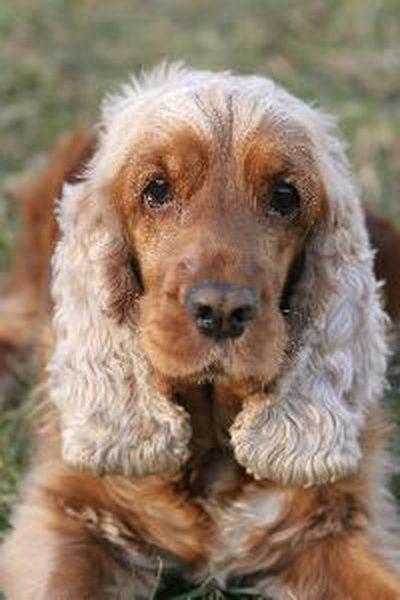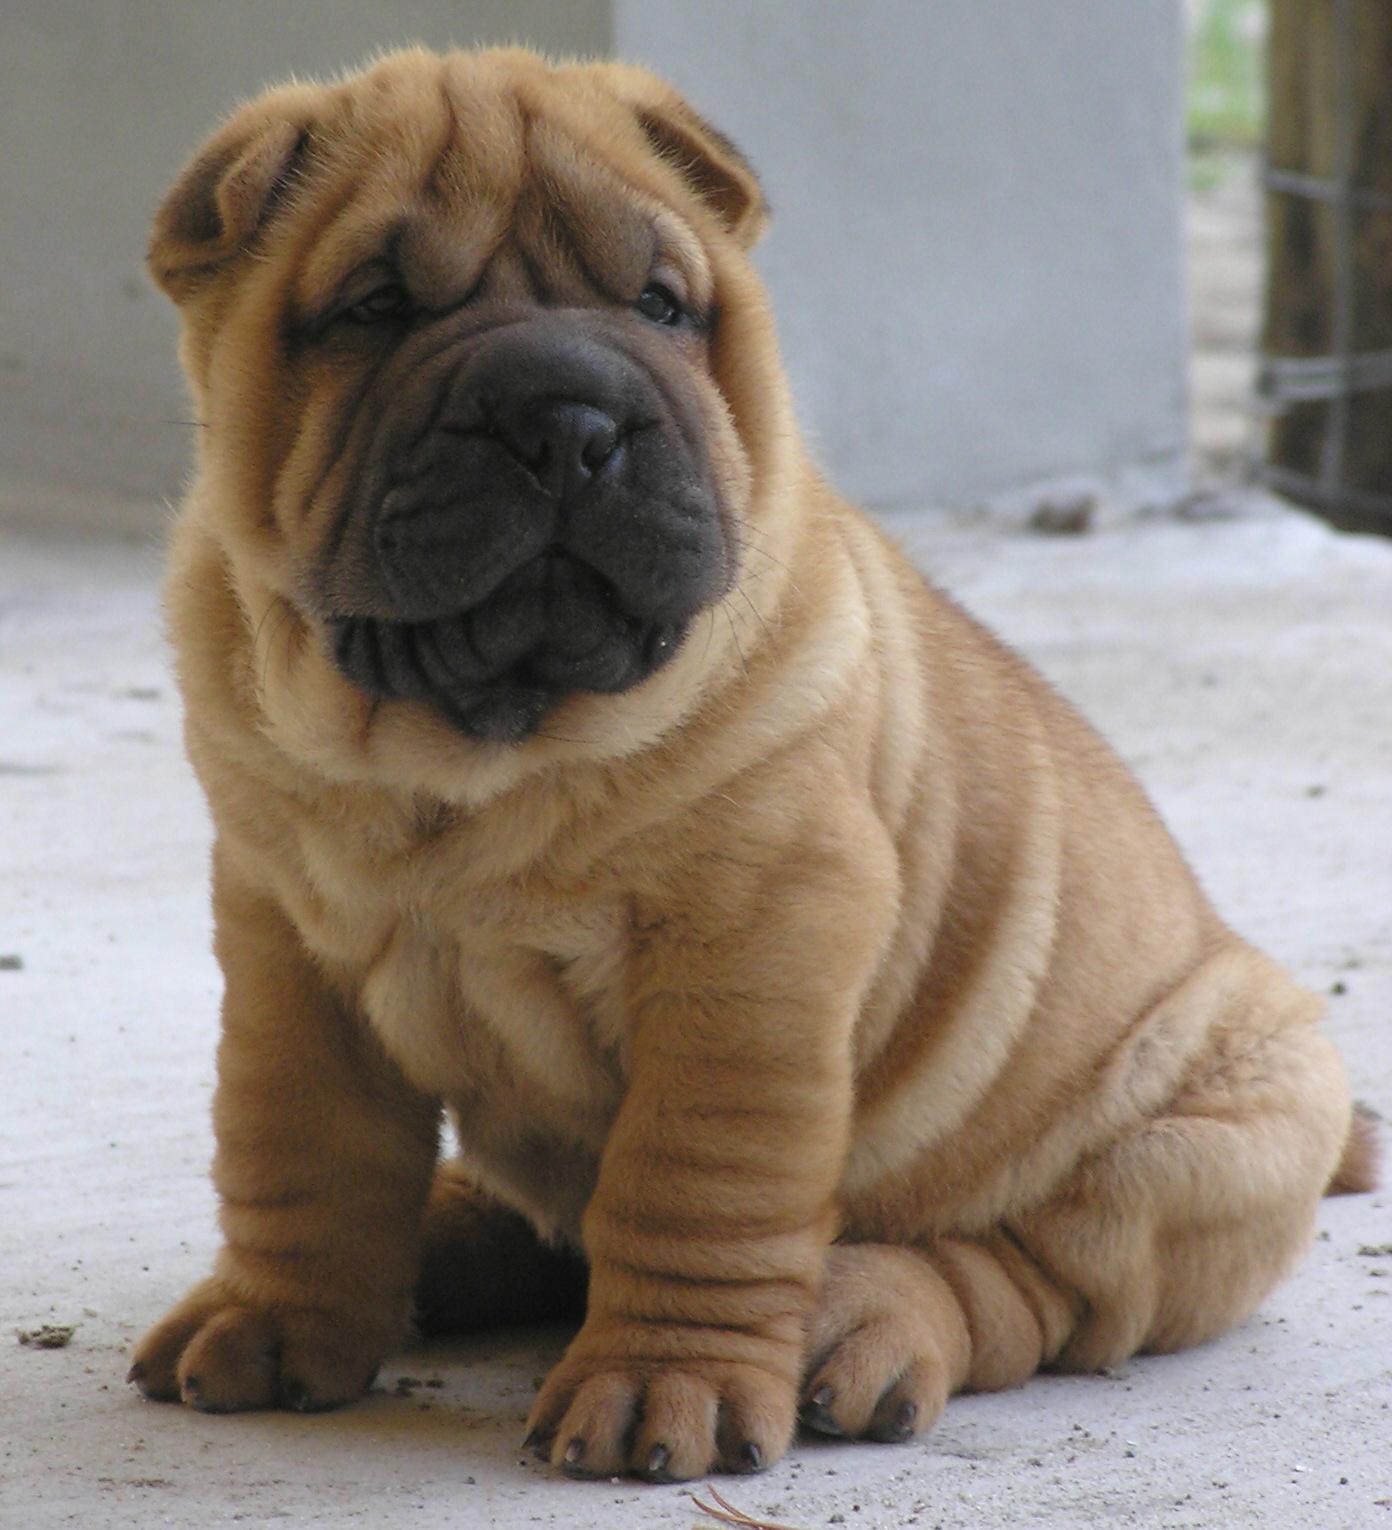The first image is the image on the left, the second image is the image on the right. For the images shown, is this caption "The dog in the image on the right is sitting." true? Answer yes or no. Yes. 